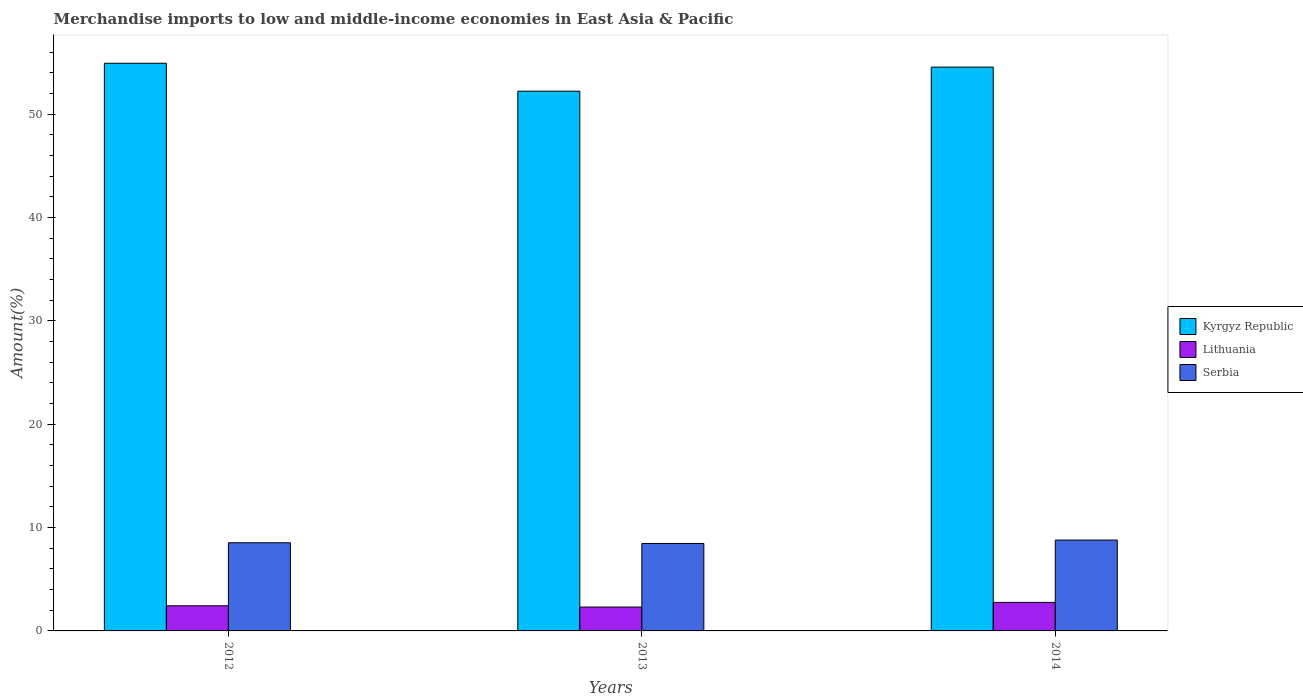How many different coloured bars are there?
Your answer should be compact. 3. Are the number of bars on each tick of the X-axis equal?
Offer a very short reply. Yes. How many bars are there on the 2nd tick from the left?
Offer a terse response. 3. What is the percentage of amount earned from merchandise imports in Serbia in 2013?
Keep it short and to the point. 8.46. Across all years, what is the maximum percentage of amount earned from merchandise imports in Kyrgyz Republic?
Provide a succinct answer. 54.93. Across all years, what is the minimum percentage of amount earned from merchandise imports in Kyrgyz Republic?
Your answer should be compact. 52.23. What is the total percentage of amount earned from merchandise imports in Serbia in the graph?
Offer a terse response. 25.79. What is the difference between the percentage of amount earned from merchandise imports in Serbia in 2013 and that in 2014?
Provide a short and direct response. -0.33. What is the difference between the percentage of amount earned from merchandise imports in Lithuania in 2014 and the percentage of amount earned from merchandise imports in Kyrgyz Republic in 2012?
Make the answer very short. -52.17. What is the average percentage of amount earned from merchandise imports in Kyrgyz Republic per year?
Provide a succinct answer. 53.91. In the year 2013, what is the difference between the percentage of amount earned from merchandise imports in Kyrgyz Republic and percentage of amount earned from merchandise imports in Serbia?
Provide a succinct answer. 43.77. What is the ratio of the percentage of amount earned from merchandise imports in Serbia in 2013 to that in 2014?
Give a very brief answer. 0.96. Is the percentage of amount earned from merchandise imports in Lithuania in 2012 less than that in 2013?
Provide a short and direct response. No. What is the difference between the highest and the second highest percentage of amount earned from merchandise imports in Serbia?
Make the answer very short. 0.26. What is the difference between the highest and the lowest percentage of amount earned from merchandise imports in Serbia?
Give a very brief answer. 0.33. In how many years, is the percentage of amount earned from merchandise imports in Serbia greater than the average percentage of amount earned from merchandise imports in Serbia taken over all years?
Offer a terse response. 1. Is the sum of the percentage of amount earned from merchandise imports in Kyrgyz Republic in 2013 and 2014 greater than the maximum percentage of amount earned from merchandise imports in Serbia across all years?
Keep it short and to the point. Yes. What does the 2nd bar from the left in 2013 represents?
Your response must be concise. Lithuania. What does the 3rd bar from the right in 2013 represents?
Make the answer very short. Kyrgyz Republic. How many bars are there?
Offer a very short reply. 9. How many years are there in the graph?
Provide a succinct answer. 3. What is the difference between two consecutive major ticks on the Y-axis?
Give a very brief answer. 10. What is the title of the graph?
Offer a terse response. Merchandise imports to low and middle-income economies in East Asia & Pacific. Does "Madagascar" appear as one of the legend labels in the graph?
Provide a succinct answer. No. What is the label or title of the X-axis?
Keep it short and to the point. Years. What is the label or title of the Y-axis?
Make the answer very short. Amount(%). What is the Amount(%) of Kyrgyz Republic in 2012?
Keep it short and to the point. 54.93. What is the Amount(%) in Lithuania in 2012?
Give a very brief answer. 2.43. What is the Amount(%) in Serbia in 2012?
Provide a short and direct response. 8.53. What is the Amount(%) of Kyrgyz Republic in 2013?
Your answer should be very brief. 52.23. What is the Amount(%) in Lithuania in 2013?
Offer a very short reply. 2.31. What is the Amount(%) in Serbia in 2013?
Your answer should be compact. 8.46. What is the Amount(%) in Kyrgyz Republic in 2014?
Make the answer very short. 54.56. What is the Amount(%) of Lithuania in 2014?
Offer a terse response. 2.76. What is the Amount(%) of Serbia in 2014?
Provide a short and direct response. 8.79. Across all years, what is the maximum Amount(%) in Kyrgyz Republic?
Make the answer very short. 54.93. Across all years, what is the maximum Amount(%) in Lithuania?
Provide a short and direct response. 2.76. Across all years, what is the maximum Amount(%) of Serbia?
Make the answer very short. 8.79. Across all years, what is the minimum Amount(%) of Kyrgyz Republic?
Make the answer very short. 52.23. Across all years, what is the minimum Amount(%) of Lithuania?
Your response must be concise. 2.31. Across all years, what is the minimum Amount(%) in Serbia?
Your response must be concise. 8.46. What is the total Amount(%) of Kyrgyz Republic in the graph?
Ensure brevity in your answer.  161.73. What is the total Amount(%) in Lithuania in the graph?
Offer a terse response. 7.5. What is the total Amount(%) in Serbia in the graph?
Ensure brevity in your answer.  25.79. What is the difference between the Amount(%) in Kyrgyz Republic in 2012 and that in 2013?
Offer a very short reply. 2.7. What is the difference between the Amount(%) in Lithuania in 2012 and that in 2013?
Provide a short and direct response. 0.12. What is the difference between the Amount(%) of Serbia in 2012 and that in 2013?
Your answer should be very brief. 0.07. What is the difference between the Amount(%) of Kyrgyz Republic in 2012 and that in 2014?
Offer a terse response. 0.37. What is the difference between the Amount(%) in Lithuania in 2012 and that in 2014?
Give a very brief answer. -0.33. What is the difference between the Amount(%) of Serbia in 2012 and that in 2014?
Your response must be concise. -0.26. What is the difference between the Amount(%) of Kyrgyz Republic in 2013 and that in 2014?
Your answer should be very brief. -2.33. What is the difference between the Amount(%) in Lithuania in 2013 and that in 2014?
Ensure brevity in your answer.  -0.45. What is the difference between the Amount(%) of Serbia in 2013 and that in 2014?
Provide a short and direct response. -0.33. What is the difference between the Amount(%) of Kyrgyz Republic in 2012 and the Amount(%) of Lithuania in 2013?
Your answer should be compact. 52.62. What is the difference between the Amount(%) in Kyrgyz Republic in 2012 and the Amount(%) in Serbia in 2013?
Your response must be concise. 46.47. What is the difference between the Amount(%) of Lithuania in 2012 and the Amount(%) of Serbia in 2013?
Your answer should be very brief. -6.03. What is the difference between the Amount(%) of Kyrgyz Republic in 2012 and the Amount(%) of Lithuania in 2014?
Provide a short and direct response. 52.17. What is the difference between the Amount(%) in Kyrgyz Republic in 2012 and the Amount(%) in Serbia in 2014?
Provide a short and direct response. 46.14. What is the difference between the Amount(%) of Lithuania in 2012 and the Amount(%) of Serbia in 2014?
Your response must be concise. -6.36. What is the difference between the Amount(%) in Kyrgyz Republic in 2013 and the Amount(%) in Lithuania in 2014?
Offer a very short reply. 49.47. What is the difference between the Amount(%) in Kyrgyz Republic in 2013 and the Amount(%) in Serbia in 2014?
Your answer should be compact. 43.44. What is the difference between the Amount(%) in Lithuania in 2013 and the Amount(%) in Serbia in 2014?
Your answer should be compact. -6.48. What is the average Amount(%) in Kyrgyz Republic per year?
Keep it short and to the point. 53.91. What is the average Amount(%) of Lithuania per year?
Provide a succinct answer. 2.5. What is the average Amount(%) in Serbia per year?
Offer a very short reply. 8.6. In the year 2012, what is the difference between the Amount(%) in Kyrgyz Republic and Amount(%) in Lithuania?
Your answer should be very brief. 52.5. In the year 2012, what is the difference between the Amount(%) in Kyrgyz Republic and Amount(%) in Serbia?
Ensure brevity in your answer.  46.4. In the year 2012, what is the difference between the Amount(%) in Lithuania and Amount(%) in Serbia?
Offer a very short reply. -6.1. In the year 2013, what is the difference between the Amount(%) of Kyrgyz Republic and Amount(%) of Lithuania?
Keep it short and to the point. 49.92. In the year 2013, what is the difference between the Amount(%) in Kyrgyz Republic and Amount(%) in Serbia?
Provide a succinct answer. 43.77. In the year 2013, what is the difference between the Amount(%) in Lithuania and Amount(%) in Serbia?
Offer a very short reply. -6.15. In the year 2014, what is the difference between the Amount(%) of Kyrgyz Republic and Amount(%) of Lithuania?
Your response must be concise. 51.8. In the year 2014, what is the difference between the Amount(%) of Kyrgyz Republic and Amount(%) of Serbia?
Offer a very short reply. 45.77. In the year 2014, what is the difference between the Amount(%) in Lithuania and Amount(%) in Serbia?
Make the answer very short. -6.03. What is the ratio of the Amount(%) of Kyrgyz Republic in 2012 to that in 2013?
Provide a succinct answer. 1.05. What is the ratio of the Amount(%) of Lithuania in 2012 to that in 2013?
Provide a succinct answer. 1.05. What is the ratio of the Amount(%) in Kyrgyz Republic in 2012 to that in 2014?
Give a very brief answer. 1.01. What is the ratio of the Amount(%) in Lithuania in 2012 to that in 2014?
Your answer should be very brief. 0.88. What is the ratio of the Amount(%) in Serbia in 2012 to that in 2014?
Ensure brevity in your answer.  0.97. What is the ratio of the Amount(%) in Kyrgyz Republic in 2013 to that in 2014?
Make the answer very short. 0.96. What is the ratio of the Amount(%) of Lithuania in 2013 to that in 2014?
Make the answer very short. 0.84. What is the ratio of the Amount(%) of Serbia in 2013 to that in 2014?
Ensure brevity in your answer.  0.96. What is the difference between the highest and the second highest Amount(%) of Kyrgyz Republic?
Make the answer very short. 0.37. What is the difference between the highest and the second highest Amount(%) of Lithuania?
Your answer should be compact. 0.33. What is the difference between the highest and the second highest Amount(%) in Serbia?
Your answer should be very brief. 0.26. What is the difference between the highest and the lowest Amount(%) in Kyrgyz Republic?
Your answer should be very brief. 2.7. What is the difference between the highest and the lowest Amount(%) of Lithuania?
Give a very brief answer. 0.45. What is the difference between the highest and the lowest Amount(%) in Serbia?
Your answer should be compact. 0.33. 